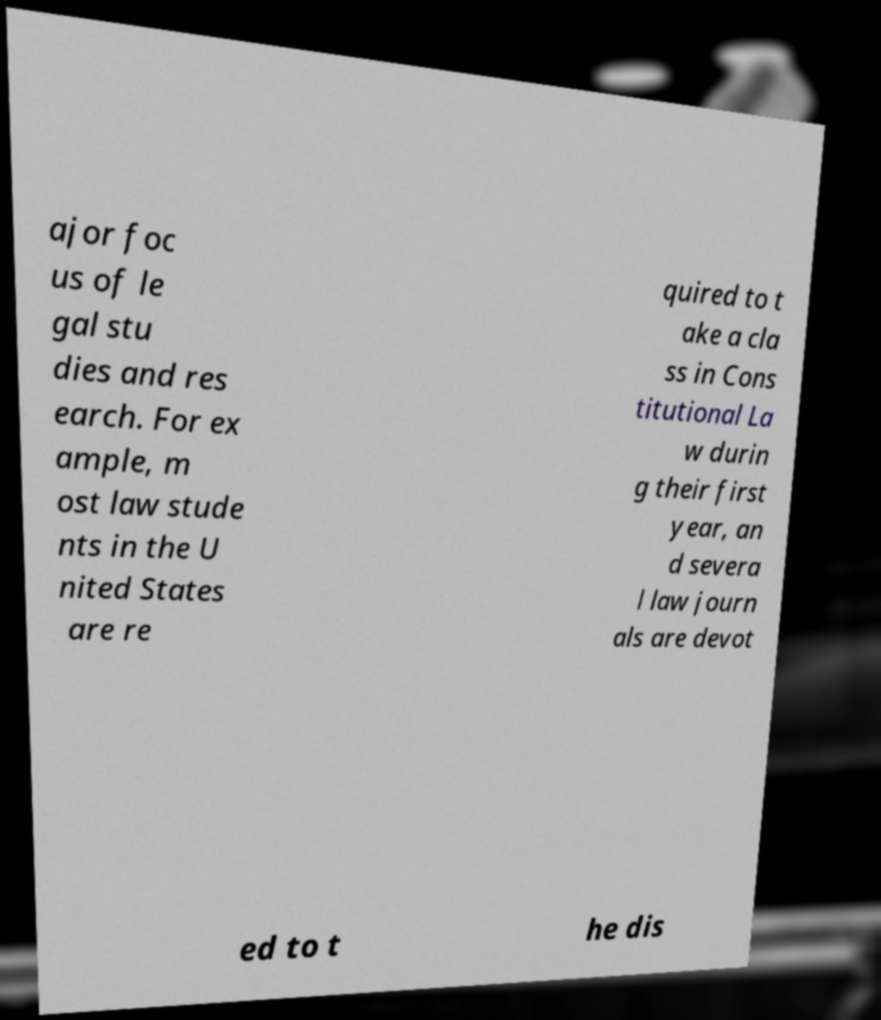Please read and relay the text visible in this image. What does it say? ajor foc us of le gal stu dies and res earch. For ex ample, m ost law stude nts in the U nited States are re quired to t ake a cla ss in Cons titutional La w durin g their first year, an d severa l law journ als are devot ed to t he dis 